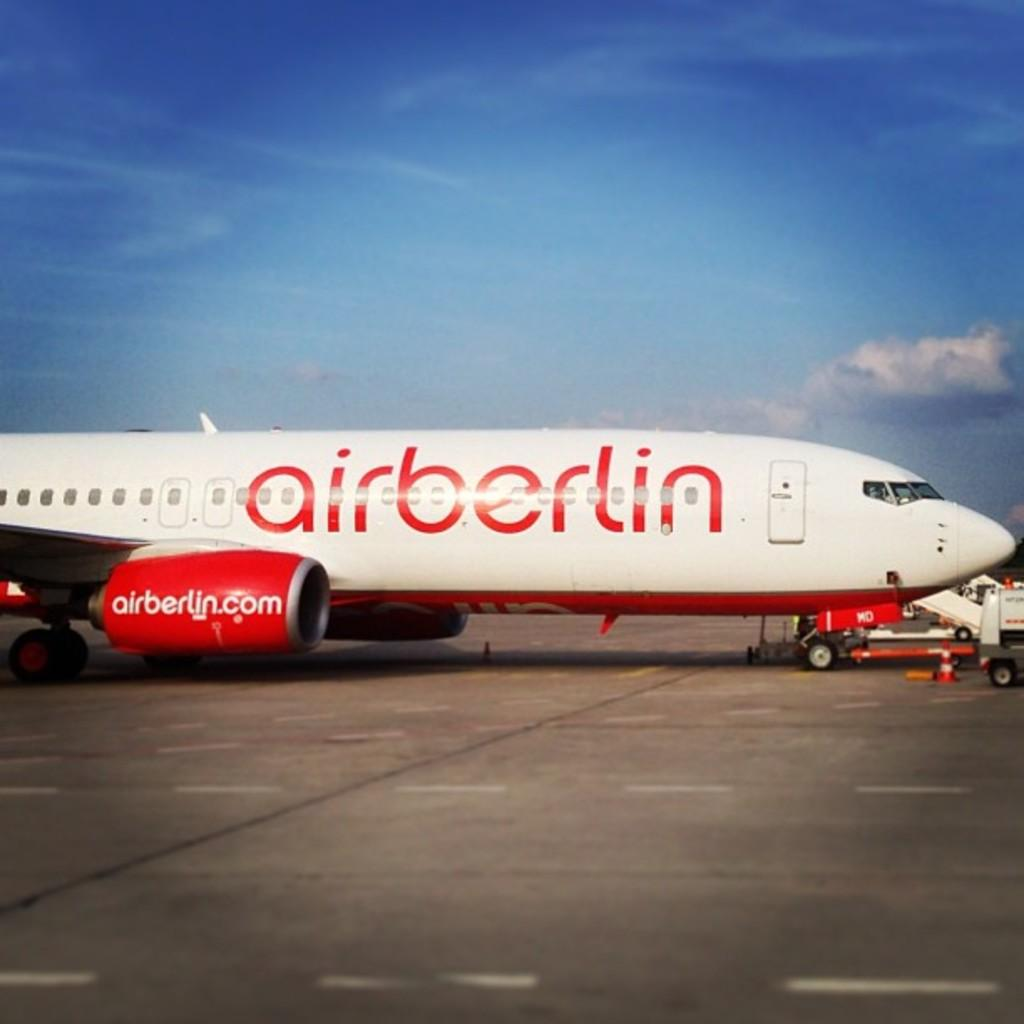Provide a one-sentence caption for the provided image. A white and red plane is labeled airberlin. 